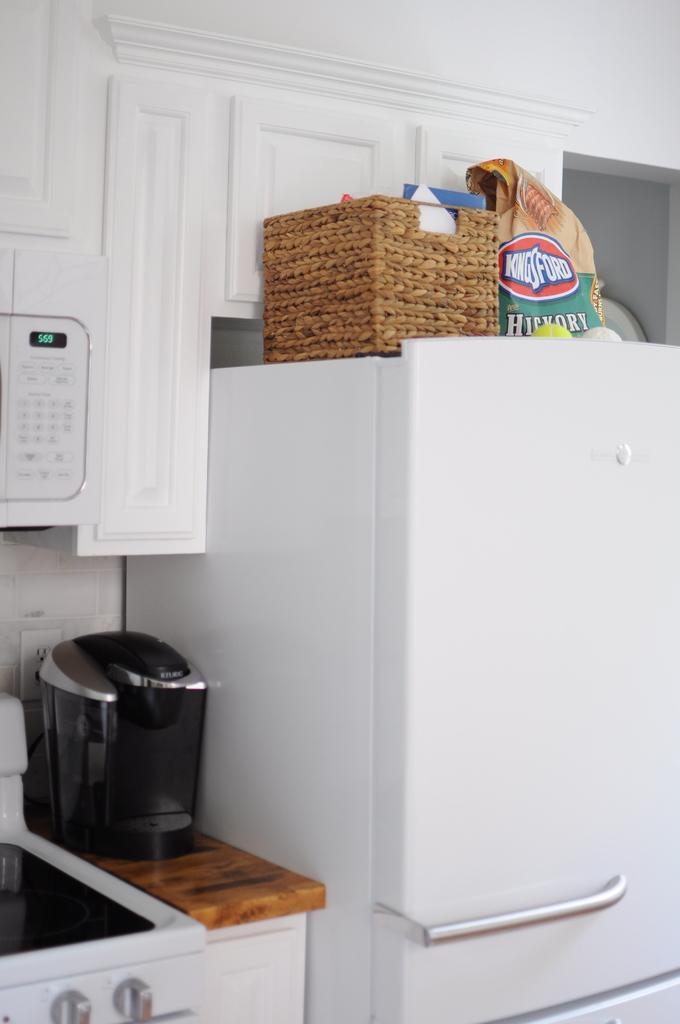<image>
Create a compact narrative representing the image presented. A kitchen filled with an oven, coffee maker, and charcol, among other things. 